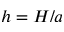<formula> <loc_0><loc_0><loc_500><loc_500>h = H / a</formula> 